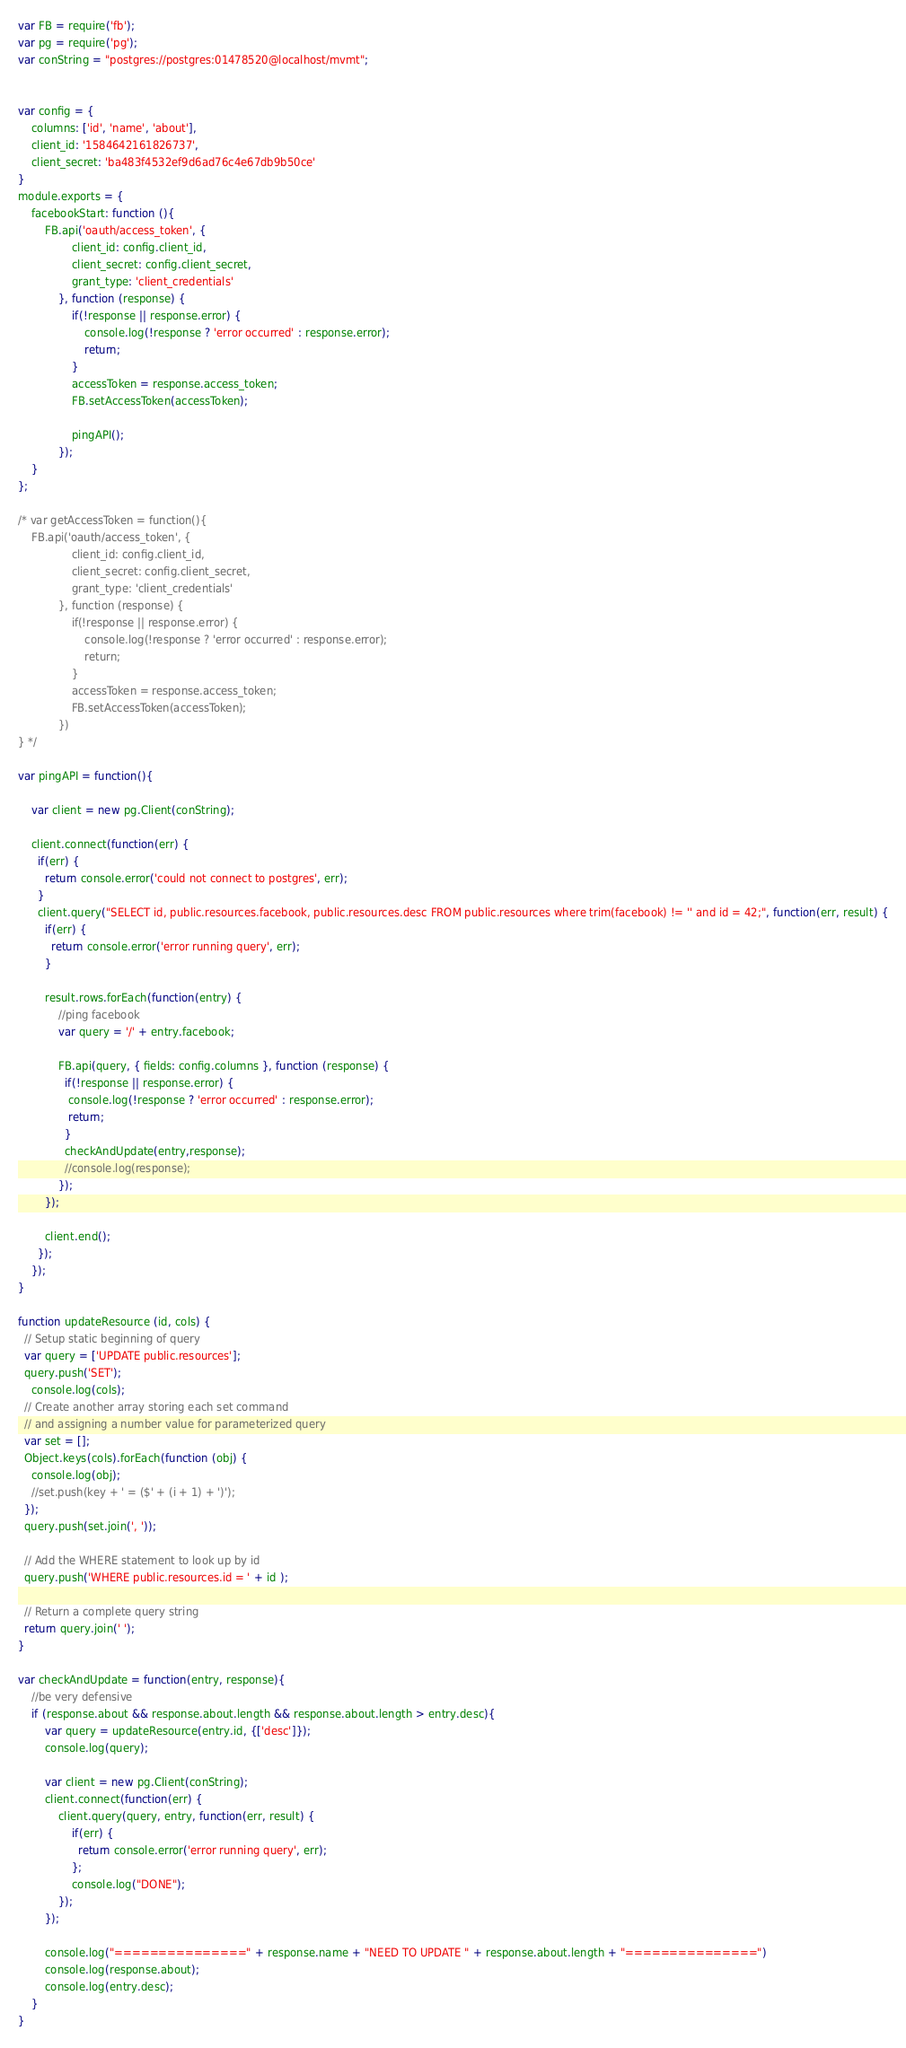Convert code to text. <code><loc_0><loc_0><loc_500><loc_500><_JavaScript_>var FB = require('fb');
var pg = require('pg');
var conString = "postgres://postgres:01478520@localhost/mvmt";


var config = {
	columns: ['id', 'name', 'about'],
	client_id: '1584642161826737',
	client_secret: 'ba483f4532ef9d6ad76c4e67db9b50ce'
}
module.exports = {
	facebookStart: function (){
		FB.api('oauth/access_token', {
				client_id: config.client_id,
				client_secret: config.client_secret,
				grant_type: 'client_credentials'
			}, function (response) {
				if(!response || response.error) {
					console.log(!response ? 'error occurred' : response.error);
					return;
				}
				accessToken = response.access_token;
				FB.setAccessToken(accessToken);

				pingAPI();
			});
	}
};

/* var getAccessToken = function(){
	FB.api('oauth/access_token', {
				client_id: config.client_id,
				client_secret: config.client_secret,
				grant_type: 'client_credentials'
			}, function (response) {
				if(!response || response.error) {
					console.log(!response ? 'error occurred' : response.error);
					return;
				}
				accessToken = response.access_token;
				FB.setAccessToken(accessToken);
			})
} */

var pingAPI = function(){
	
	var client = new pg.Client(conString);
	
	client.connect(function(err) {
	  if(err) {
		return console.error('could not connect to postgres', err);
	  }
	  client.query("SELECT id, public.resources.facebook, public.resources.desc FROM public.resources where trim(facebook) != '' and id = 42;", function(err, result) {
		if(err) {
		  return console.error('error running query', err);
		}
		
		result.rows.forEach(function(entry) {
			//ping facebook
			var query = '/' + entry.facebook;
			
			FB.api(query, { fields: config.columns }, function (response) {
			  if(!response || response.error) {
			   console.log(!response ? 'error occurred' : response.error);
			   return;
			  }
			  checkAndUpdate(entry,response);
			  //console.log(response);
			});
		});
		
		client.end();
	  });
	});
}

function updateResource (id, cols) {
  // Setup static beginning of query
  var query = ['UPDATE public.resources'];
  query.push('SET');
	console.log(cols);
  // Create another array storing each set command
  // and assigning a number value for parameterized query
  var set = [];
  Object.keys(cols).forEach(function (obj) {
	console.log(obj);
    //set.push(key + ' = ($' + (i + 1) + ')'); 
  });
  query.push(set.join(', '));

  // Add the WHERE statement to look up by id
  query.push('WHERE public.resources.id = ' + id );

  // Return a complete query string
  return query.join(' ');
}

var checkAndUpdate = function(entry, response){
	//be very defensive
	if (response.about && response.about.length && response.about.length > entry.desc){
		var query = updateResource(entry.id, {['desc']});
		console.log(query);
		
		var client = new pg.Client(conString);
		client.connect(function(err) {
			client.query(query, entry, function(err, result) {
				if(err) {
				  return console.error('error running query', err);
				};
				console.log("DONE");
			});
		});	
		
		console.log("===============" + response.name + "NEED TO UPDATE " + response.about.length + "===============")
		console.log(response.about);
		console.log(entry.desc);
	}
}</code> 